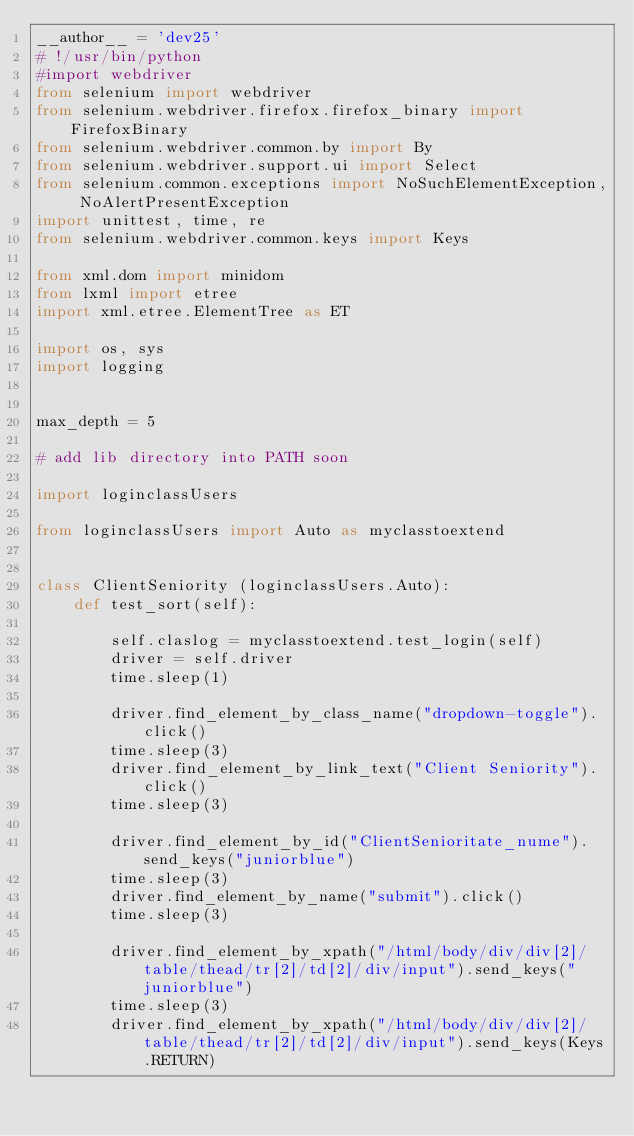Convert code to text. <code><loc_0><loc_0><loc_500><loc_500><_Python_>__author__ = 'dev25'
# !/usr/bin/python
#import webdriver
from selenium import webdriver
from selenium.webdriver.firefox.firefox_binary import FirefoxBinary
from selenium.webdriver.common.by import By
from selenium.webdriver.support.ui import Select
from selenium.common.exceptions import NoSuchElementException, NoAlertPresentException
import unittest, time, re
from selenium.webdriver.common.keys import Keys

from xml.dom import minidom
from lxml import etree
import xml.etree.ElementTree as ET

import os, sys
import logging


max_depth = 5

# add lib directory into PATH soon

import loginclassUsers

from loginclassUsers import Auto as myclasstoextend


class ClientSeniority (loginclassUsers.Auto):
    def test_sort(self):

        self.claslog = myclasstoextend.test_login(self)
        driver = self.driver
        time.sleep(1)

        driver.find_element_by_class_name("dropdown-toggle").click()
        time.sleep(3)
        driver.find_element_by_link_text("Client Seniority").click()
        time.sleep(3)

        driver.find_element_by_id("ClientSenioritate_nume").send_keys("juniorblue")
        time.sleep(3)
        driver.find_element_by_name("submit").click()
        time.sleep(3)

        driver.find_element_by_xpath("/html/body/div/div[2]/table/thead/tr[2]/td[2]/div/input").send_keys("juniorblue")
        time.sleep(3)
        driver.find_element_by_xpath("/html/body/div/div[2]/table/thead/tr[2]/td[2]/div/input").send_keys(Keys.RETURN)
</code> 